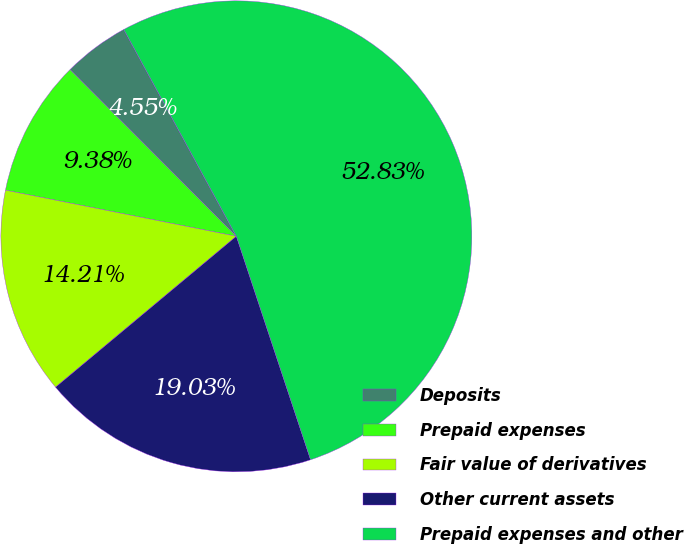Convert chart. <chart><loc_0><loc_0><loc_500><loc_500><pie_chart><fcel>Deposits<fcel>Prepaid expenses<fcel>Fair value of derivatives<fcel>Other current assets<fcel>Prepaid expenses and other<nl><fcel>4.55%<fcel>9.38%<fcel>14.21%<fcel>19.03%<fcel>52.83%<nl></chart> 